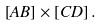Convert formula to latex. <formula><loc_0><loc_0><loc_500><loc_500>\left [ A B \right ] \times \left [ C D \right ] .</formula> 